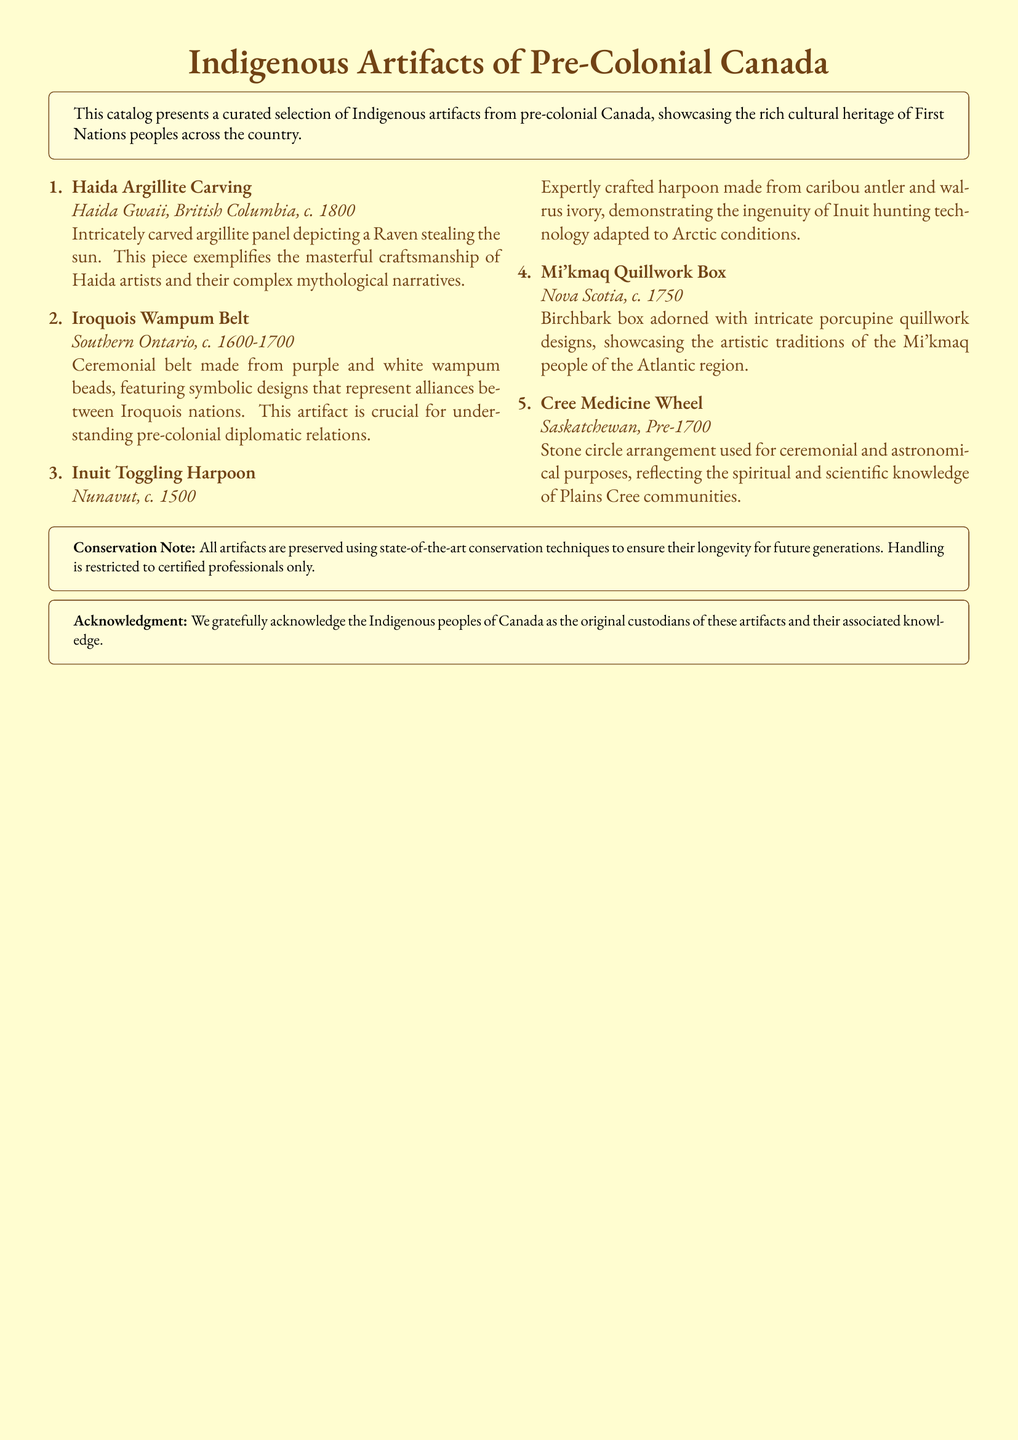What is the title of the catalog? The title of the catalog is prominently displayed at the top of the document.
Answer: Indigenous Artifacts of Pre-Colonial Canada How many artifacts are listed in the catalog? The number of artifacts can be counted from the list presented in the document.
Answer: 5 What is the creation date of the Haida Argillite Carving? The date is provided in the description of the Haida Argillite Carving.
Answer: c. 1800 Which artifact features a ceremonial belt? The document specifically mentions the type of artifact in its description.
Answer: Iroquois Wampum Belt What material is the Inuit Toggling Harpoon made from? The materials used for the Inuit Toggling Harpoon are mentioned in its description.
Answer: Caribou antler and walrus ivory What region is associated with the Mi'kmaq Quillwork Box? The region is stated in the description of the artifact.
Answer: Nova Scotia What type of artifact is described as having intricate porcupine quillwork designs? The description highlights the specific nature of the artifact.
Answer: Birchbark box What is the purpose of the Cree Medicine Wheel? The purpose is specified in the description of the Cree Medicine Wheel artifact.
Answer: Ceremonial and astronomical Who are acknowledged as the original custodians of the artifacts? This acknowledgment is included in a specific section of the document.
Answer: Indigenous peoples of Canada 